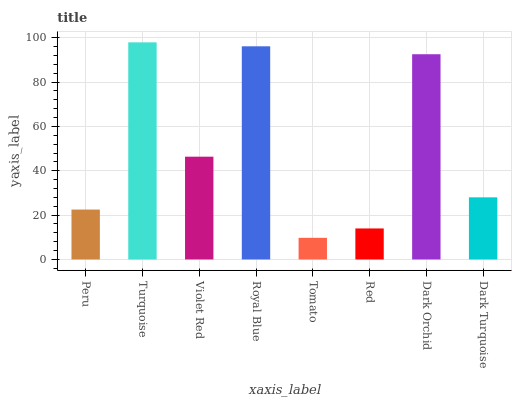Is Tomato the minimum?
Answer yes or no. Yes. Is Turquoise the maximum?
Answer yes or no. Yes. Is Violet Red the minimum?
Answer yes or no. No. Is Violet Red the maximum?
Answer yes or no. No. Is Turquoise greater than Violet Red?
Answer yes or no. Yes. Is Violet Red less than Turquoise?
Answer yes or no. Yes. Is Violet Red greater than Turquoise?
Answer yes or no. No. Is Turquoise less than Violet Red?
Answer yes or no. No. Is Violet Red the high median?
Answer yes or no. Yes. Is Dark Turquoise the low median?
Answer yes or no. Yes. Is Red the high median?
Answer yes or no. No. Is Peru the low median?
Answer yes or no. No. 